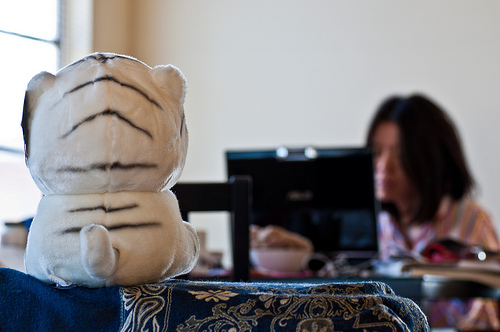<image>
Is the toy in front of the girl? Yes. The toy is positioned in front of the girl, appearing closer to the camera viewpoint. Is the girl in front of the computer? No. The girl is not in front of the computer. The spatial positioning shows a different relationship between these objects. 